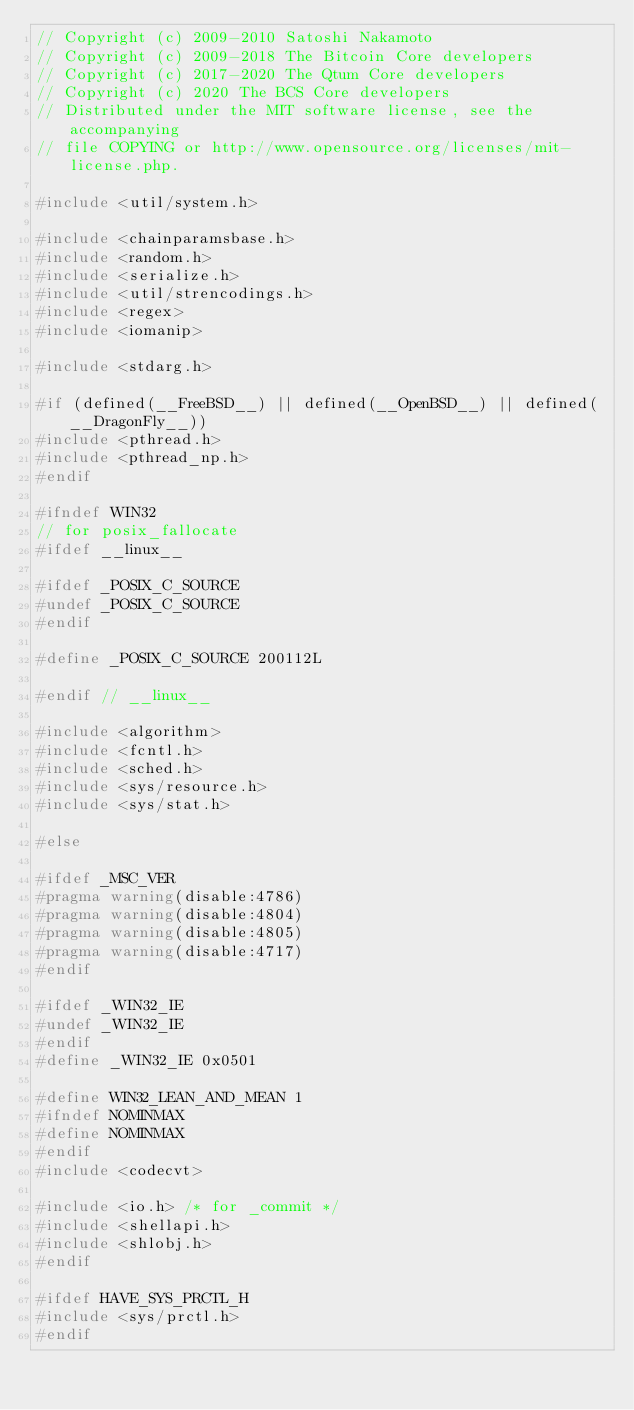<code> <loc_0><loc_0><loc_500><loc_500><_C++_>// Copyright (c) 2009-2010 Satoshi Nakamoto
// Copyright (c) 2009-2018 The Bitcoin Core developers
// Copyright (c) 2017-2020 The Qtum Core developers
// Copyright (c) 2020 The BCS Core developers
// Distributed under the MIT software license, see the accompanying
// file COPYING or http://www.opensource.org/licenses/mit-license.php.

#include <util/system.h>

#include <chainparamsbase.h>
#include <random.h>
#include <serialize.h>
#include <util/strencodings.h>
#include <regex>
#include <iomanip>

#include <stdarg.h>

#if (defined(__FreeBSD__) || defined(__OpenBSD__) || defined(__DragonFly__))
#include <pthread.h>
#include <pthread_np.h>
#endif

#ifndef WIN32
// for posix_fallocate
#ifdef __linux__

#ifdef _POSIX_C_SOURCE
#undef _POSIX_C_SOURCE
#endif

#define _POSIX_C_SOURCE 200112L

#endif // __linux__

#include <algorithm>
#include <fcntl.h>
#include <sched.h>
#include <sys/resource.h>
#include <sys/stat.h>

#else

#ifdef _MSC_VER
#pragma warning(disable:4786)
#pragma warning(disable:4804)
#pragma warning(disable:4805)
#pragma warning(disable:4717)
#endif

#ifdef _WIN32_IE
#undef _WIN32_IE
#endif
#define _WIN32_IE 0x0501

#define WIN32_LEAN_AND_MEAN 1
#ifndef NOMINMAX
#define NOMINMAX
#endif
#include <codecvt>

#include <io.h> /* for _commit */
#include <shellapi.h>
#include <shlobj.h>
#endif

#ifdef HAVE_SYS_PRCTL_H
#include <sys/prctl.h>
#endif
</code> 